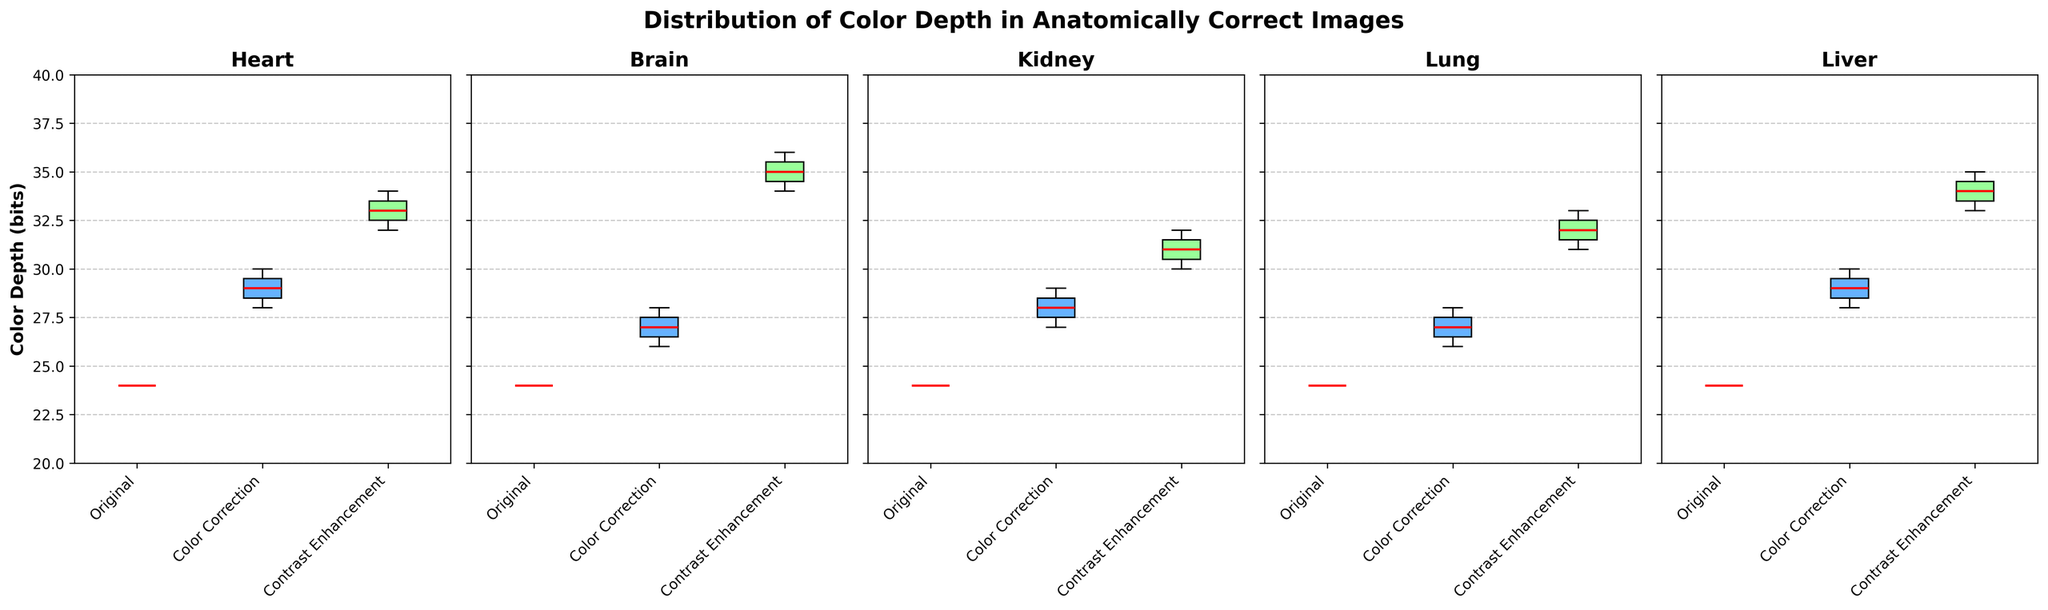What is the title of the figure? The title is directly displayed at the top of the figure, usually in a larger or bolder font.
Answer: "Distribution of Color Depth in Anatomically Correct Images" What is the y-axis label for these plots? The y-axis label is positioned along the vertical axis and indicates the variable being measured.
Answer: "Color Depth (bits)" Which editing technique for the Heart specimen has the highest median color depth? By inspecting the box plot of the Heart specimen, the median is indicated by the red line in the box plot. The Contrast Enhancement box plot has the highest median line.
Answer: Contrast Enhancement Is the median color depth higher for the Brain or Kidney specimen under Contrast Enhancement? Look at the red median lines in the box plots for both specimens under Contrast Enhancement. The Brain has a higher median color depth compared to the Kidney.
Answer: Brain Which specimen shows the largest increase in color depth due to Contrast Enhancement compared to the Original technique? Compare the distances between the median lines of each specimen's Original and Contrast Enhancement box plots. The Brain shows the largest median increase from 24 bits to 35 bits.
Answer: Brain What is the range of color depth values for the Lung specimen under Color Correction? The range is calculated from the ends of the whiskers, representing the minimum and maximum values. For the Lung in Color Correction, it ranges from 26 to 28 bits.
Answer: 26-28 bits Are there any outliers present for the Heart specimen under any editing technique? Outliers are typically shown as individual points outside the whiskers. For the Heart, there are no outliers present in any technique's boxplot.
Answer: No How does the spread (interquartile range) of Color Depth for the Liver specimen under Original compare to that under Contrast Enhancement? The interquartile range (IQR) is the width of the box. For Original, it is 0 (all values are 24), while for Contrast Enhancement, it is the range from Q1 to Q3 (~33 to ~35).
Answer: Contrast Enhancement has a larger IQR Which editing technique has the lowest median color depth for all specimens? Compare the median lines across all box plots for each editing technique. The Original technique consistently has the lowest median color depth (24 bits).
Answer: Original 